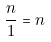<formula> <loc_0><loc_0><loc_500><loc_500>\frac { n } { 1 } = n</formula> 